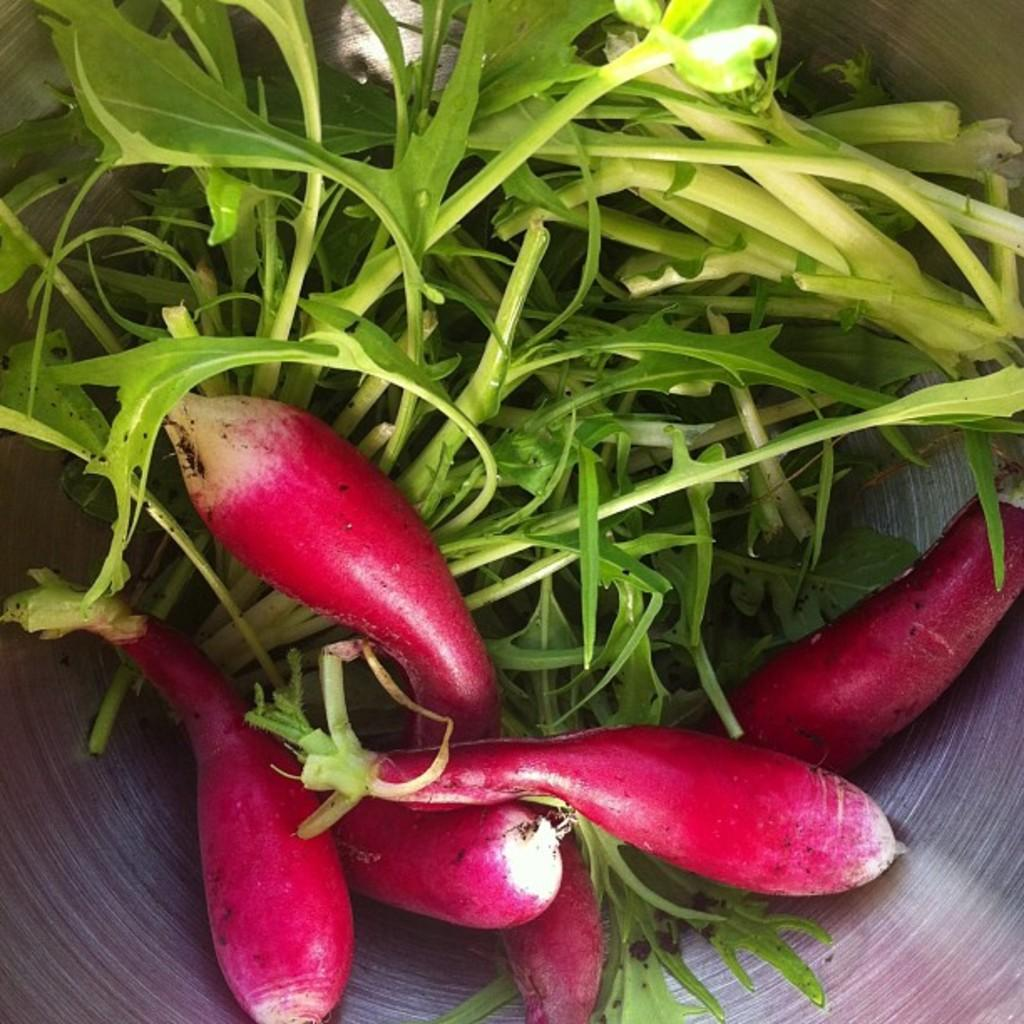What type of vegetation can be seen in the image? There are green leaves in the image. What color are the vegetables in the image? The vegetables in the image are red. How do the vegetables help their friends in the image? There are no friends or interactions between the vegetables depicted in the image. 